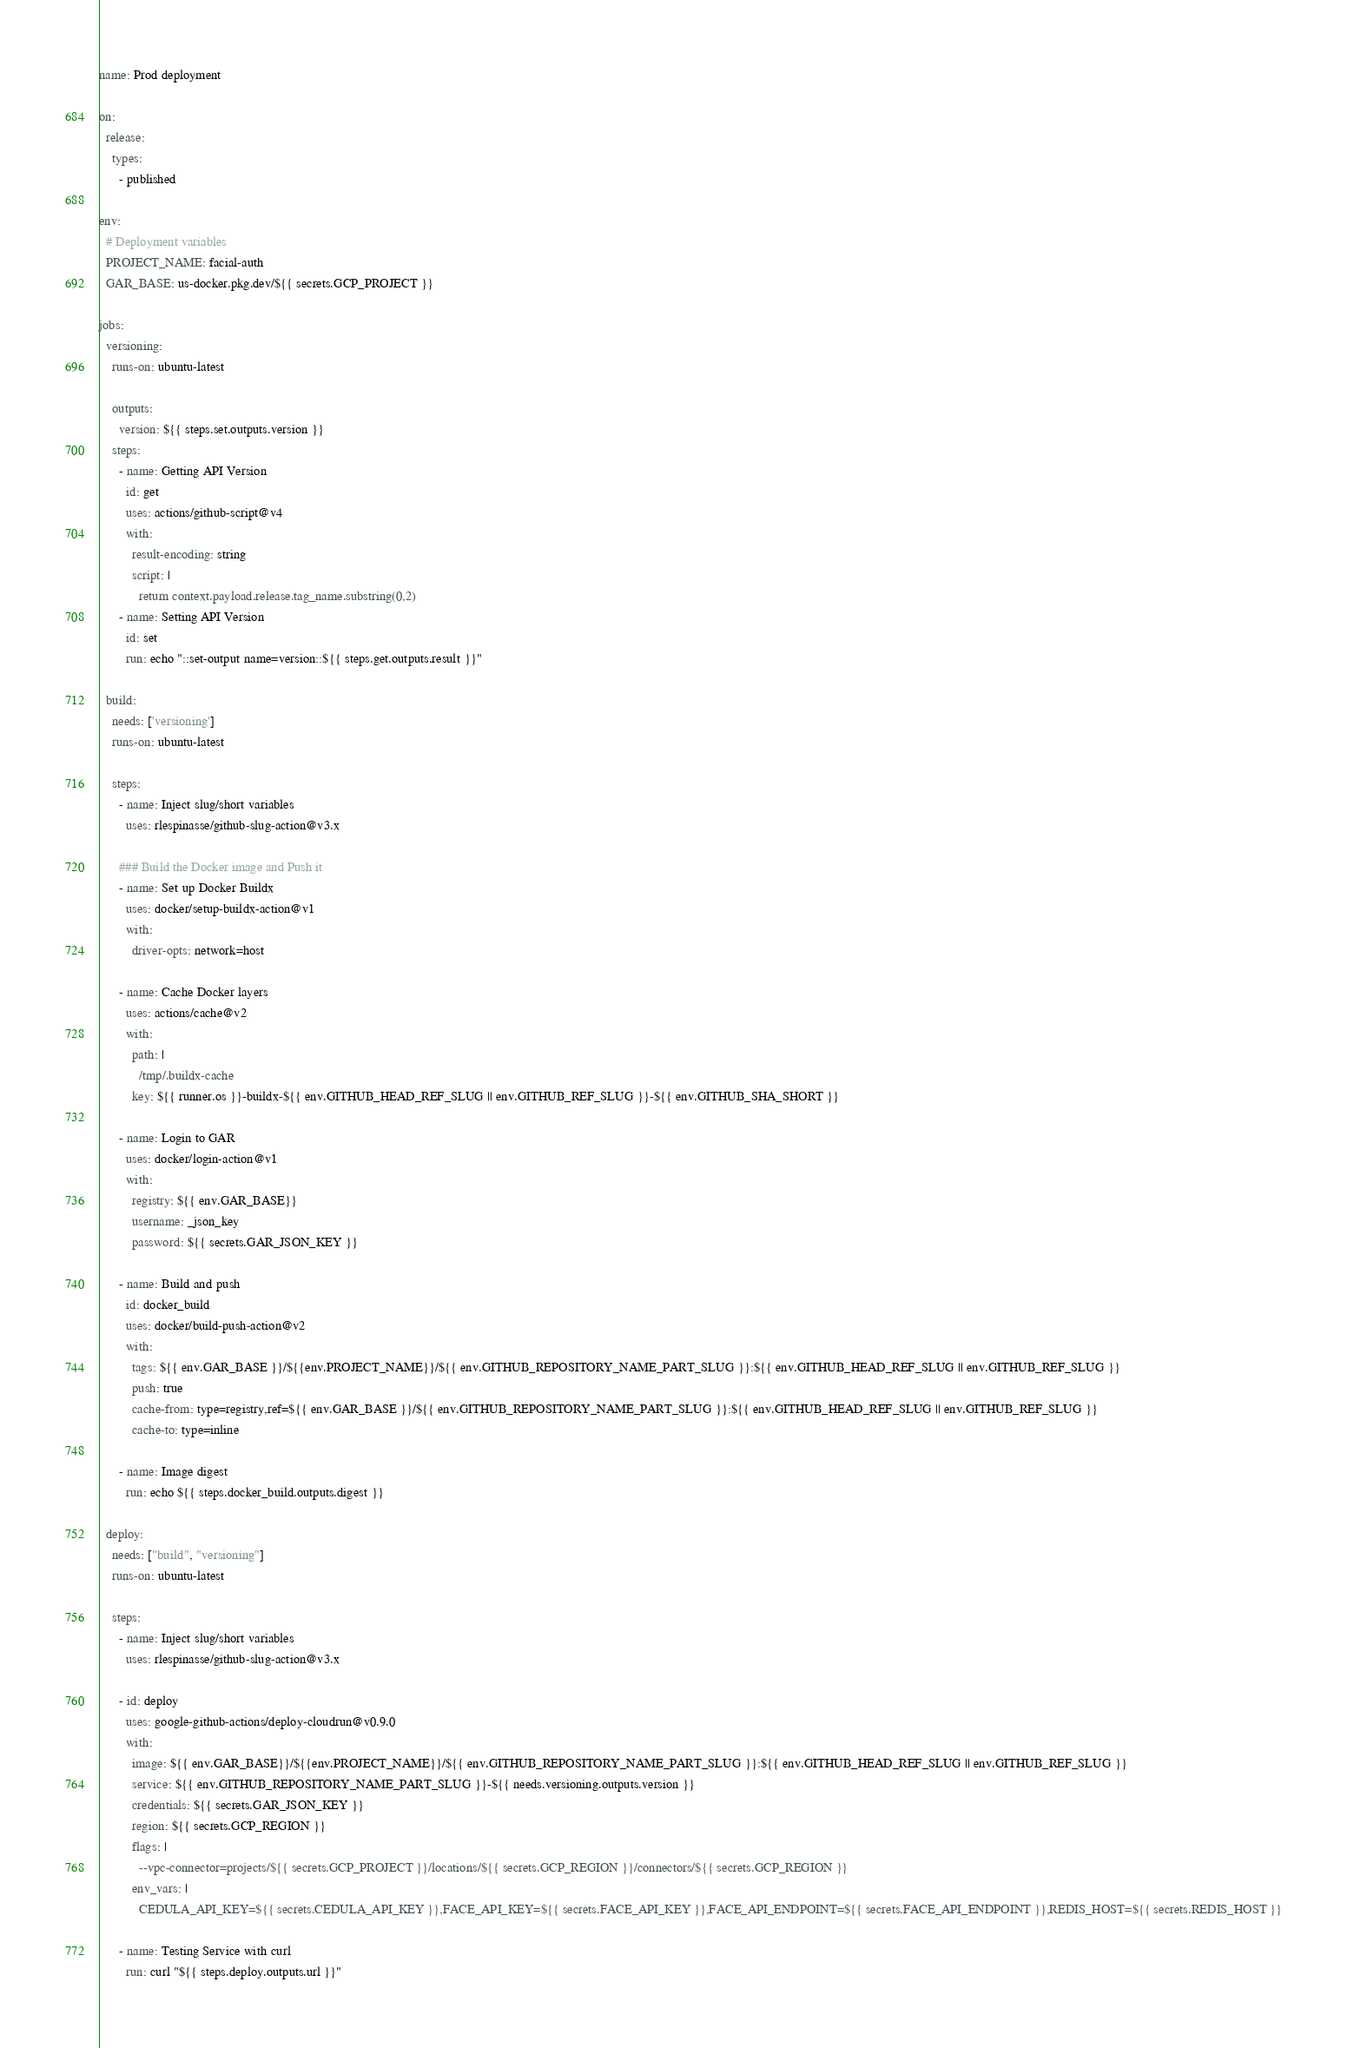<code> <loc_0><loc_0><loc_500><loc_500><_YAML_>name: Prod deployment

on:
  release:
    types:
      - published

env:
  # Deployment variables
  PROJECT_NAME: facial-auth
  GAR_BASE: us-docker.pkg.dev/${{ secrets.GCP_PROJECT }}

jobs:
  versioning:
    runs-on: ubuntu-latest

    outputs:
      version: ${{ steps.set.outputs.version }}
    steps:
      - name: Getting API Version
        id: get
        uses: actions/github-script@v4
        with:
          result-encoding: string
          script: |
            return context.payload.release.tag_name.substring(0,2)
      - name: Setting API Version
        id: set
        run: echo "::set-output name=version::${{ steps.get.outputs.result }}"

  build:
    needs: ['versioning']
    runs-on: ubuntu-latest

    steps:
      - name: Inject slug/short variables
        uses: rlespinasse/github-slug-action@v3.x

      ### Build the Docker image and Push it
      - name: Set up Docker Buildx
        uses: docker/setup-buildx-action@v1
        with:
          driver-opts: network=host

      - name: Cache Docker layers
        uses: actions/cache@v2
        with:
          path: |
            /tmp/.buildx-cache
          key: ${{ runner.os }}-buildx-${{ env.GITHUB_HEAD_REF_SLUG || env.GITHUB_REF_SLUG }}-${{ env.GITHUB_SHA_SHORT }}

      - name: Login to GAR
        uses: docker/login-action@v1
        with:
          registry: ${{ env.GAR_BASE}}
          username: _json_key
          password: ${{ secrets.GAR_JSON_KEY }}

      - name: Build and push
        id: docker_build
        uses: docker/build-push-action@v2
        with:
          tags: ${{ env.GAR_BASE }}/${{env.PROJECT_NAME}}/${{ env.GITHUB_REPOSITORY_NAME_PART_SLUG }}:${{ env.GITHUB_HEAD_REF_SLUG || env.GITHUB_REF_SLUG }}
          push: true
          cache-from: type=registry,ref=${{ env.GAR_BASE }}/${{ env.GITHUB_REPOSITORY_NAME_PART_SLUG }}:${{ env.GITHUB_HEAD_REF_SLUG || env.GITHUB_REF_SLUG }}
          cache-to: type=inline

      - name: Image digest
        run: echo ${{ steps.docker_build.outputs.digest }}

  deploy:
    needs: ["build", "versioning"]
    runs-on: ubuntu-latest

    steps:
      - name: Inject slug/short variables
        uses: rlespinasse/github-slug-action@v3.x

      - id: deploy
        uses: google-github-actions/deploy-cloudrun@v0.9.0
        with:
          image: ${{ env.GAR_BASE}}/${{env.PROJECT_NAME}}/${{ env.GITHUB_REPOSITORY_NAME_PART_SLUG }}:${{ env.GITHUB_HEAD_REF_SLUG || env.GITHUB_REF_SLUG }}
          service: ${{ env.GITHUB_REPOSITORY_NAME_PART_SLUG }}-${{ needs.versioning.outputs.version }}
          credentials: ${{ secrets.GAR_JSON_KEY }}
          region: ${{ secrets.GCP_REGION }}
          flags: |
            --vpc-connector=projects/${{ secrets.GCP_PROJECT }}/locations/${{ secrets.GCP_REGION }}/connectors/${{ secrets.GCP_REGION }}
          env_vars: |
            CEDULA_API_KEY=${{ secrets.CEDULA_API_KEY }},FACE_API_KEY=${{ secrets.FACE_API_KEY }},FACE_API_ENDPOINT=${{ secrets.FACE_API_ENDPOINT }},REDIS_HOST=${{ secrets.REDIS_HOST }}

      - name: Testing Service with curl
        run: curl "${{ steps.deploy.outputs.url }}"</code> 